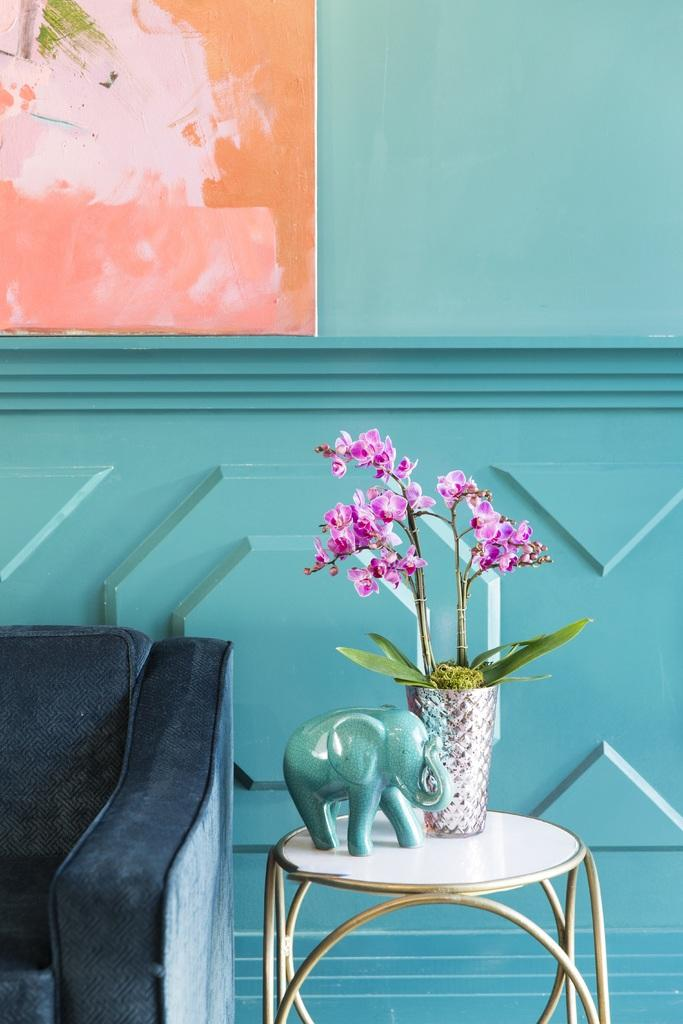What type of furniture is present in the image? There is a table and a couch in the image. What is on the table in the image? There is a flower vase on the table. What type of object is not related to furniture in the image? There is an elephant toy in the image. What can be seen on the wall in the image? There is a painted board on the wall. Can you see the uncle driving a car in the image? There is no uncle or car present in the image. 